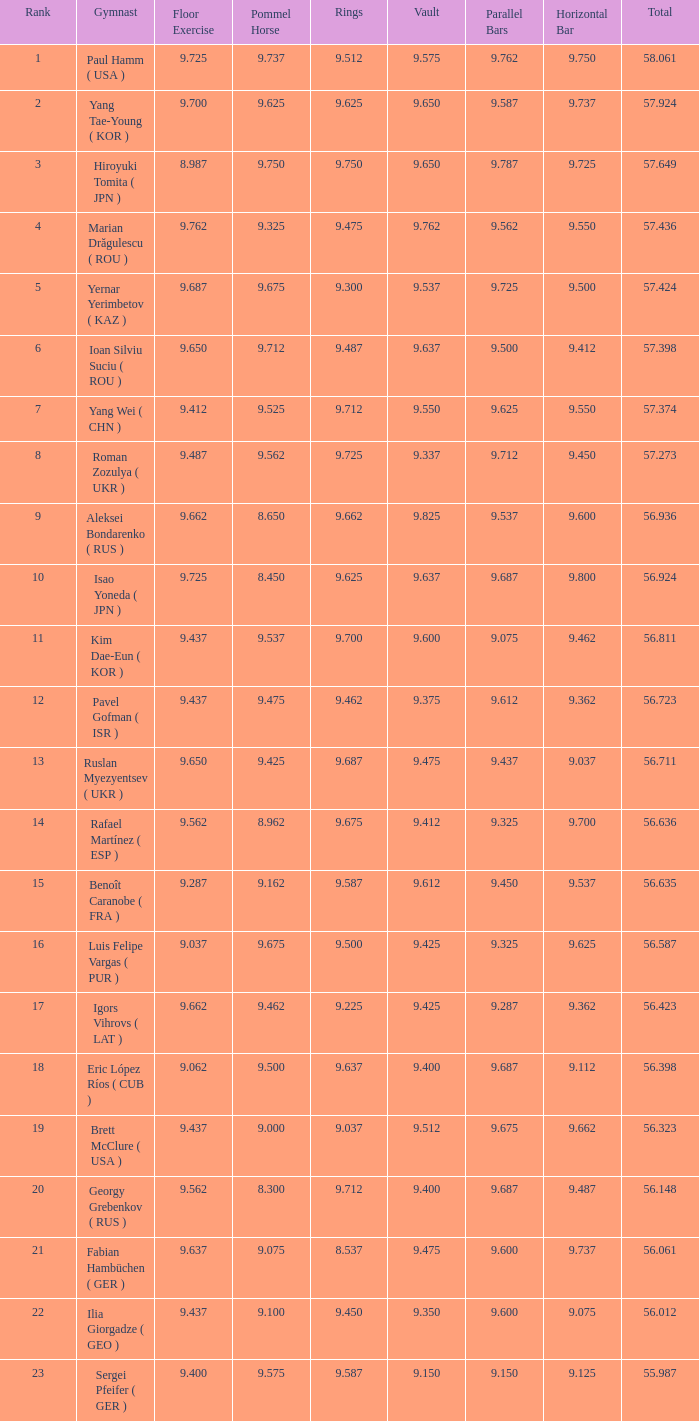For a total score of 56.635, what is the corresponding vault score? 9.612. 